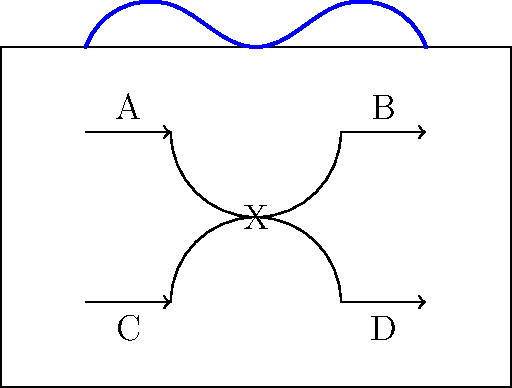Design a non-linear circuit diagram that challenges conventional thinking while maintaining functionality. The circuit should have four components (A, B, C, and D) connected through a central node X in a non-traditional layout. How would you ensure that the current flow between these components remains unaffected by the unconventional design? To create a non-linear circuit diagram that functions correctly while challenging conventional design:

1. Arrange components A, B, C, and D in a non-linear pattern, breaking away from traditional grid-like layouts.

2. Connect all components through a central node X, which acts as a hub for current flow.

3. Use curved lines to connect components, emphasizing the non-linear nature of the design.

4. Ensure that the connections maintain proper electrical continuity:
   a. Current should flow from A to B through X
   b. Current should flow from C to D through X

5. To maintain functionality:
   a. Use appropriate wire gauges to handle the current flow
   b. Implement proper insulation to prevent short circuits
   c. Ensure that the length of the curved connections does not significantly affect resistance

6. Add artistic elements to the design, such as the blue curve at the top, to symbolize the fusion of art and engineering.

7. Use arrows to indicate the direction of current flow, maintaining clarity in the unconventional layout.

8. Verify that the total resistance and voltage drops across the circuit remain consistent with a traditional linear design.

By following these steps, the circuit maintains its electrical integrity while breaking free from conventional design constraints, allowing for a creative and functional representation of electrical concepts.
Answer: Use a central node X with curved connections, maintaining proper electrical continuity and component relationships. 